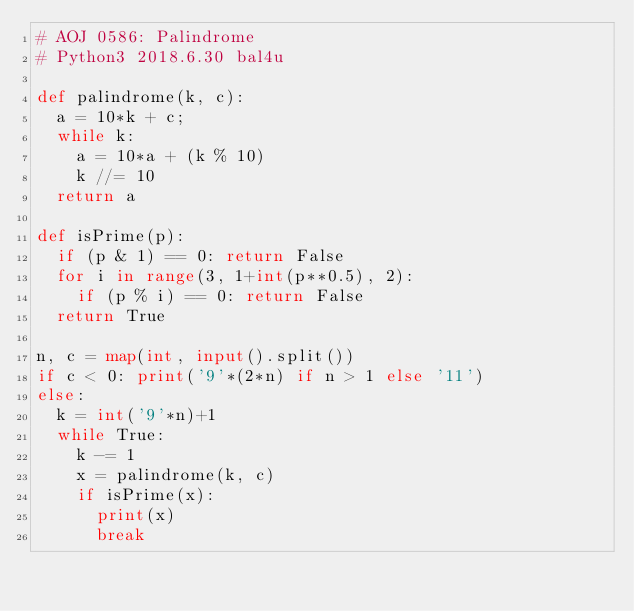<code> <loc_0><loc_0><loc_500><loc_500><_Python_># AOJ 0586: Palindrome
# Python3 2018.6.30 bal4u

def palindrome(k, c):
	a = 10*k + c;
	while k:
		a = 10*a + (k % 10)
		k //= 10
	return a

def isPrime(p):
	if (p & 1) == 0: return False
	for i in range(3, 1+int(p**0.5), 2):
		if (p % i) == 0: return False
	return True

n, c = map(int, input().split())
if c < 0: print('9'*(2*n) if n > 1 else '11')
else:
	k = int('9'*n)+1
	while True:
		k -= 1
		x = palindrome(k, c)
		if isPrime(x):
			print(x)
			break
</code> 